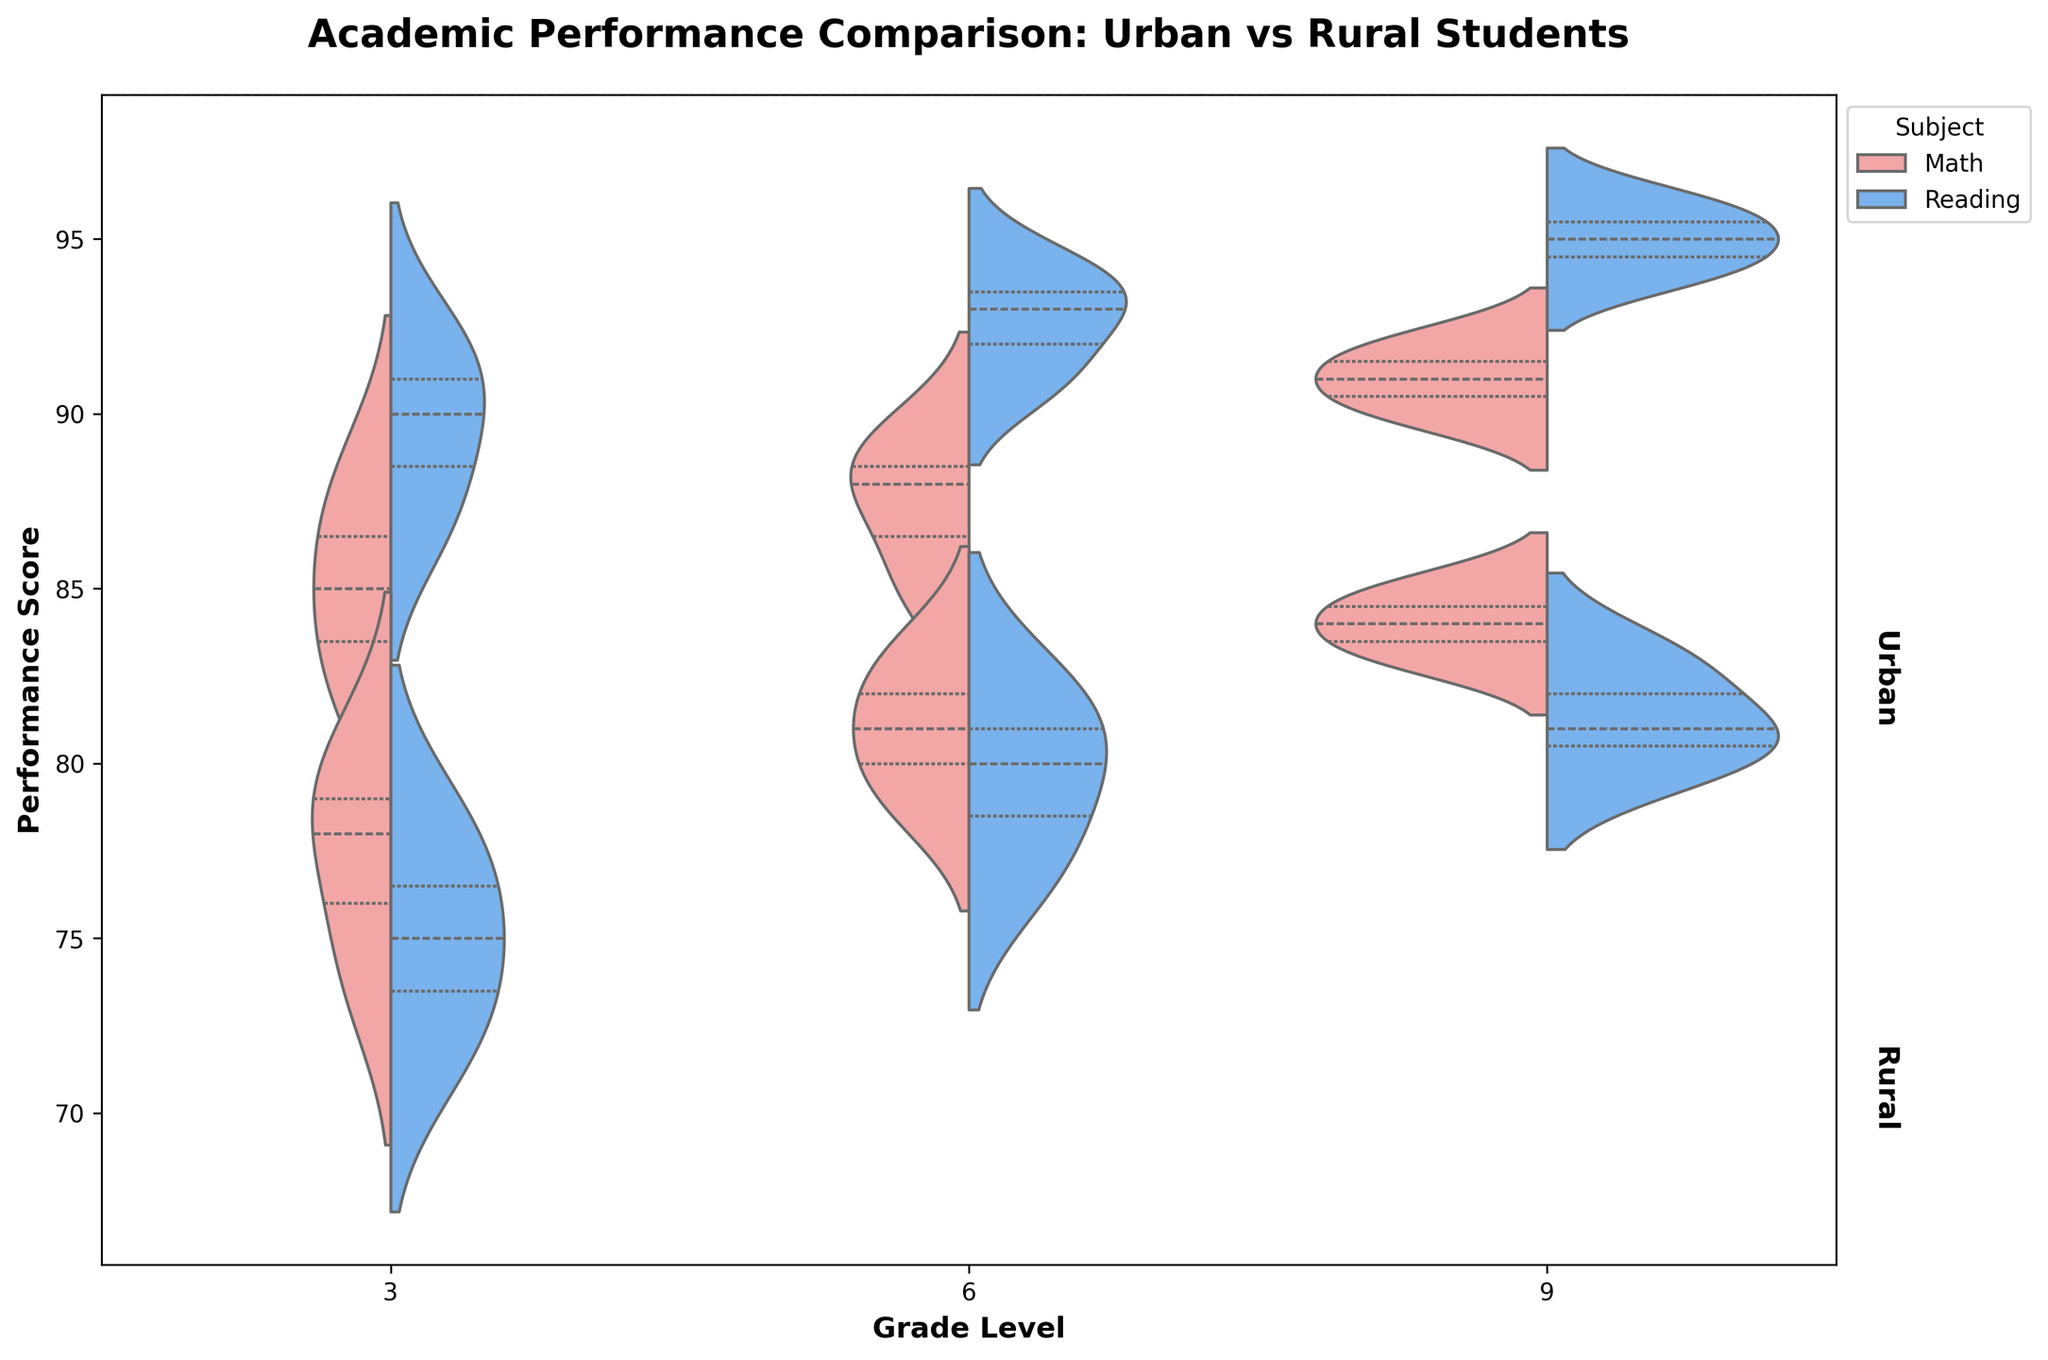What is the title of the figure? The title is displayed prominently at the top of the plot. It reads "Academic Performance Comparison: Urban vs Rural Students".
Answer: Academic Performance Comparison: Urban vs Rural Students Which grade levels are included in the figure? The x-axis has tick marks labeled with the grade levels included in the visualization. The grade levels are 3, 6, and 9.
Answer: 3, 6, 9 What subjects are compared in the figure? The legend to the right of the plot indicates the subjects being compared, which are "Math" and "Reading".
Answer: Math, Reading Which location has higher median performance scores in Grade 3 Reading? Looking at the Grade 3 reading sections, the median lines inside the urban split-violin plot are higher than those in the rural plot.
Answer: Urban Is there a visible difference in the distribution of Math performance for Grade 6 between urban and rural students? The spread of the violin plots for Math performance in Grade 6 can be compared visually. The urban plot appears higher and narrower, while the rural plot shows a wider distribution with lower scores.
Answer: Yes How do the performance distributions for urban students in Math compare across the different grade levels? By examining the height and shape of the Math sections for urban students across Grades 3, 6, and 9, it is apparent that the performance scores are higher in higher grades.
Answer: Performance scores increase with grade level Do rural students perform better in Math or Reading in Grade 9? For Grade 9, the split-violin plots show the performance of rural students in Math and Reading. The Math plot has higher median and overall values compared to the Reading plot.
Answer: Math What is the main insight about the performance gap between urban and rural students? The urban students generally score higher in both Math and Reading across all grade levels. This indicates a performance gap favoring urban students.
Answer: Urban students score higher Which grade and subject demonstrate the widest performance distribution for rural students? By comparing the width of the violin plots for rural students in different grades and subjects, it is noticeable that Grade 9 Reading has a relatively wider distribution.
Answer: Grade 9 Reading 